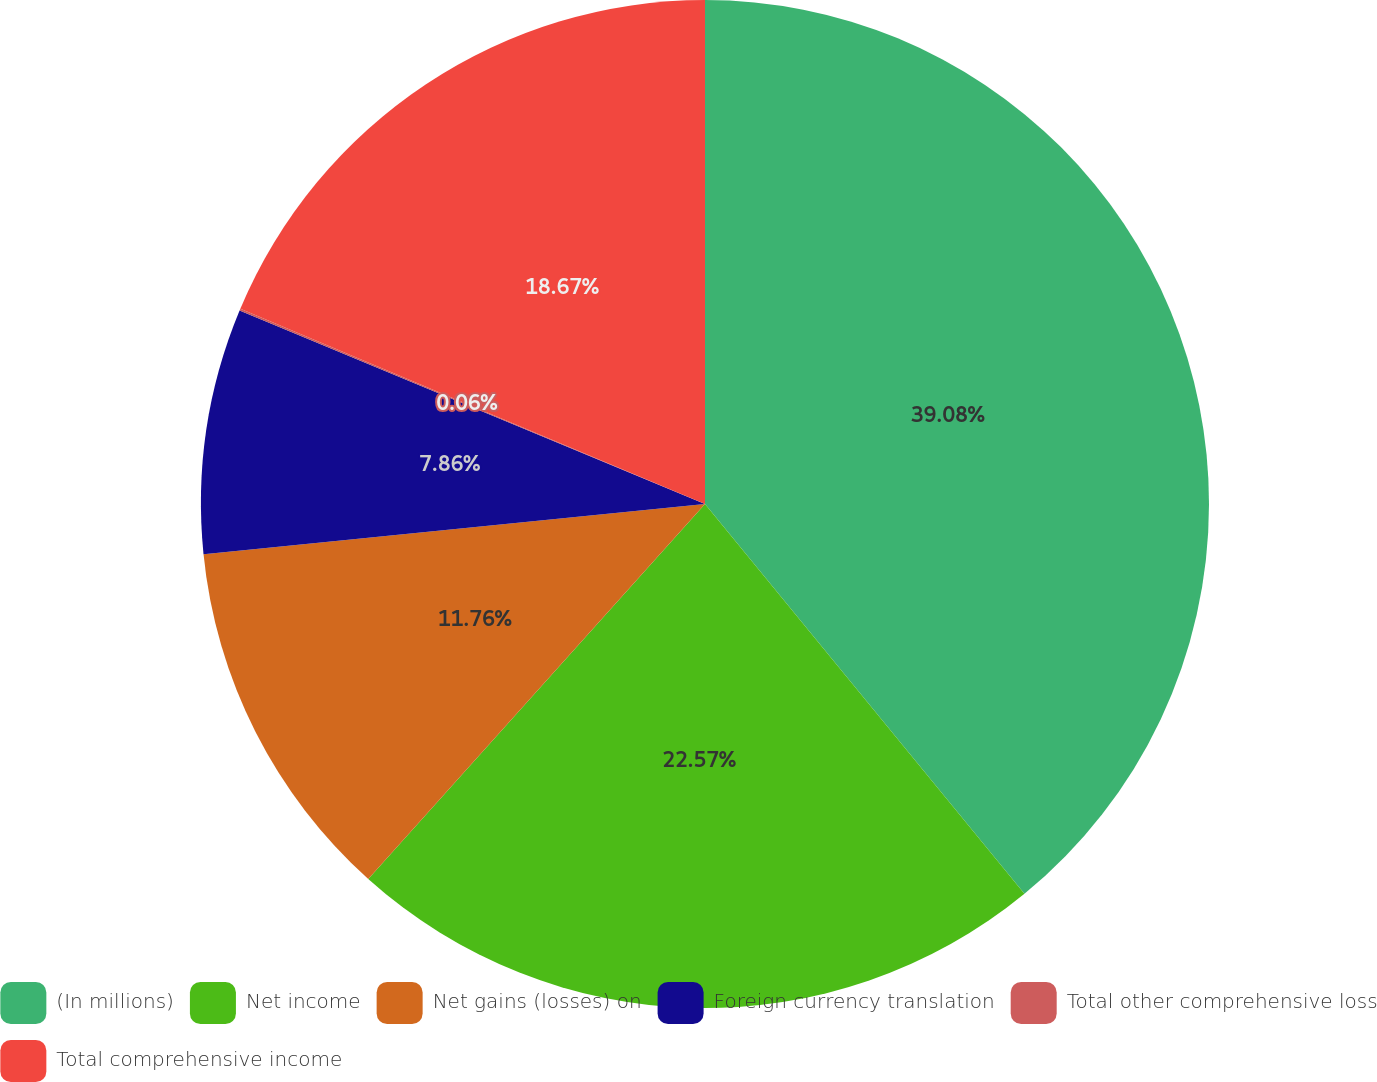<chart> <loc_0><loc_0><loc_500><loc_500><pie_chart><fcel>(In millions)<fcel>Net income<fcel>Net gains (losses) on<fcel>Foreign currency translation<fcel>Total other comprehensive loss<fcel>Total comprehensive income<nl><fcel>39.07%<fcel>22.57%<fcel>11.76%<fcel>7.86%<fcel>0.06%<fcel>18.67%<nl></chart> 